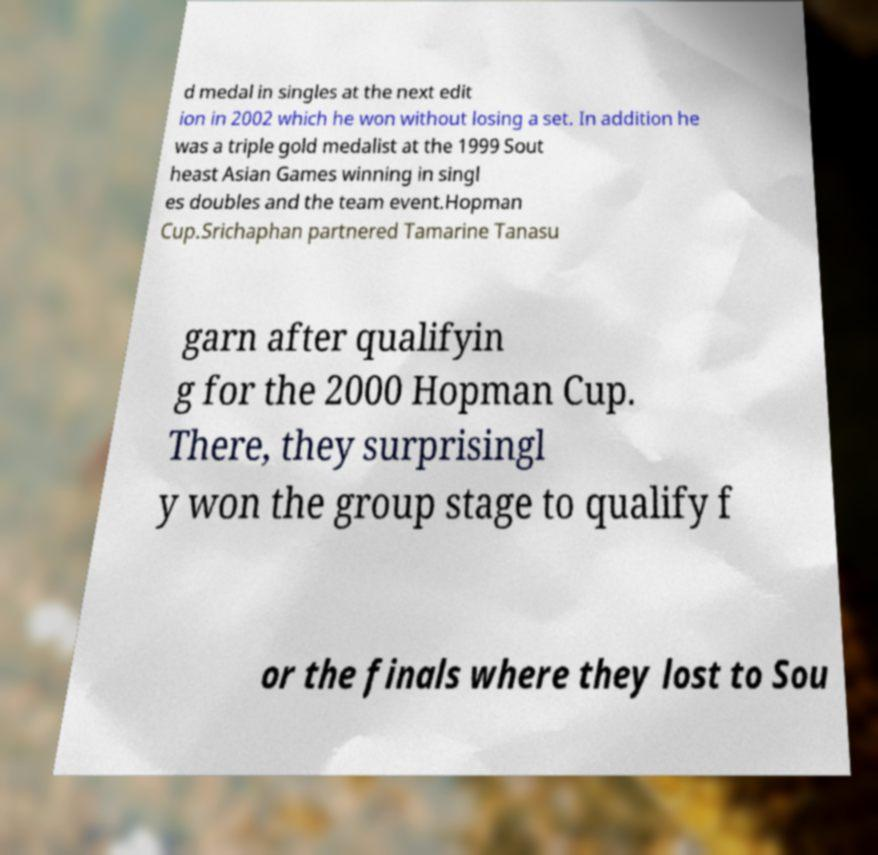Please identify and transcribe the text found in this image. d medal in singles at the next edit ion in 2002 which he won without losing a set. In addition he was a triple gold medalist at the 1999 Sout heast Asian Games winning in singl es doubles and the team event.Hopman Cup.Srichaphan partnered Tamarine Tanasu garn after qualifyin g for the 2000 Hopman Cup. There, they surprisingl y won the group stage to qualify f or the finals where they lost to Sou 